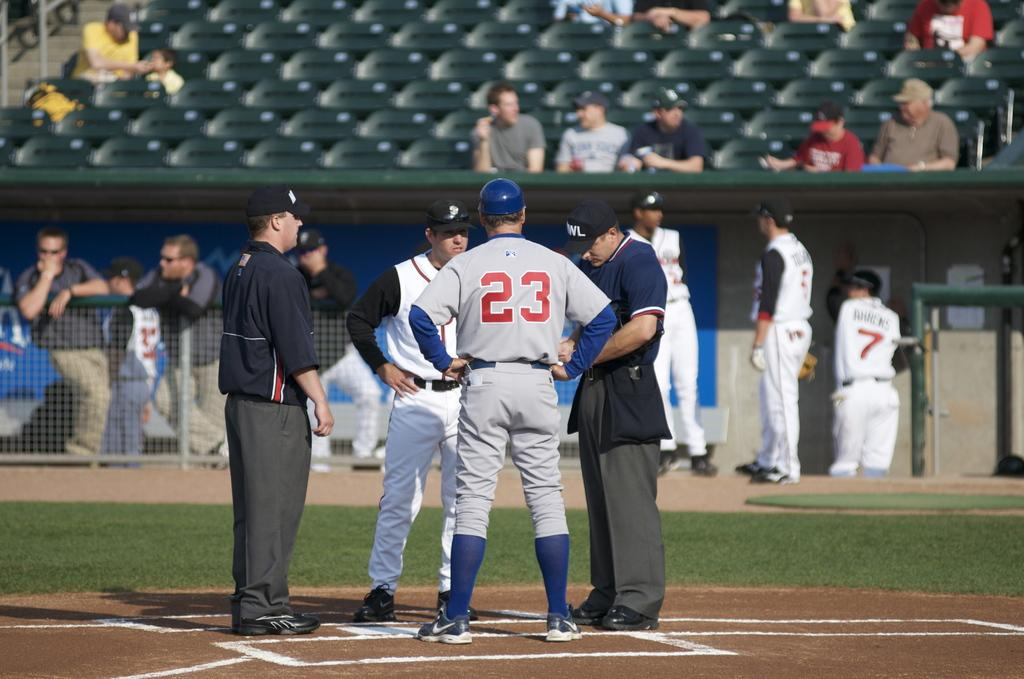<image>
Write a terse but informative summary of the picture. A baseball player with the number 23 on the back of his uniform talks with several officials on the field. 